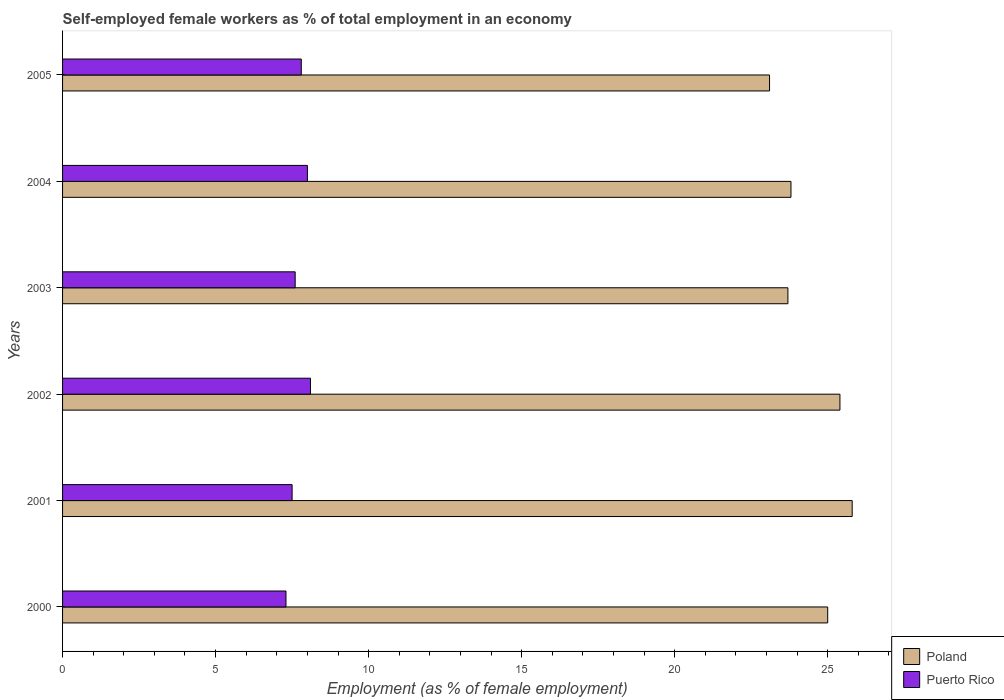How many different coloured bars are there?
Provide a short and direct response. 2. How many groups of bars are there?
Keep it short and to the point. 6. Are the number of bars per tick equal to the number of legend labels?
Ensure brevity in your answer.  Yes. How many bars are there on the 4th tick from the top?
Your answer should be very brief. 2. How many bars are there on the 1st tick from the bottom?
Provide a succinct answer. 2. What is the label of the 1st group of bars from the top?
Ensure brevity in your answer.  2005. In how many cases, is the number of bars for a given year not equal to the number of legend labels?
Your response must be concise. 0. What is the percentage of self-employed female workers in Poland in 2004?
Give a very brief answer. 23.8. Across all years, what is the maximum percentage of self-employed female workers in Poland?
Your answer should be compact. 25.8. Across all years, what is the minimum percentage of self-employed female workers in Puerto Rico?
Make the answer very short. 7.3. In which year was the percentage of self-employed female workers in Puerto Rico minimum?
Ensure brevity in your answer.  2000. What is the total percentage of self-employed female workers in Poland in the graph?
Provide a succinct answer. 146.8. What is the difference between the percentage of self-employed female workers in Puerto Rico in 2001 and that in 2005?
Give a very brief answer. -0.3. What is the difference between the percentage of self-employed female workers in Puerto Rico in 2001 and the percentage of self-employed female workers in Poland in 2002?
Make the answer very short. -17.9. What is the average percentage of self-employed female workers in Poland per year?
Make the answer very short. 24.47. In the year 2005, what is the difference between the percentage of self-employed female workers in Puerto Rico and percentage of self-employed female workers in Poland?
Your response must be concise. -15.3. What is the ratio of the percentage of self-employed female workers in Poland in 2000 to that in 2003?
Keep it short and to the point. 1.05. What is the difference between the highest and the second highest percentage of self-employed female workers in Poland?
Your answer should be very brief. 0.4. What is the difference between the highest and the lowest percentage of self-employed female workers in Puerto Rico?
Your answer should be compact. 0.8. In how many years, is the percentage of self-employed female workers in Poland greater than the average percentage of self-employed female workers in Poland taken over all years?
Provide a succinct answer. 3. Is the sum of the percentage of self-employed female workers in Puerto Rico in 2002 and 2003 greater than the maximum percentage of self-employed female workers in Poland across all years?
Your response must be concise. No. What does the 1st bar from the top in 2002 represents?
Keep it short and to the point. Puerto Rico. What does the 1st bar from the bottom in 2000 represents?
Ensure brevity in your answer.  Poland. How many bars are there?
Your response must be concise. 12. Are all the bars in the graph horizontal?
Offer a very short reply. Yes. Are the values on the major ticks of X-axis written in scientific E-notation?
Your answer should be compact. No. Does the graph contain any zero values?
Your response must be concise. No. Where does the legend appear in the graph?
Offer a terse response. Bottom right. How many legend labels are there?
Offer a very short reply. 2. How are the legend labels stacked?
Your answer should be compact. Vertical. What is the title of the graph?
Give a very brief answer. Self-employed female workers as % of total employment in an economy. Does "Turks and Caicos Islands" appear as one of the legend labels in the graph?
Offer a very short reply. No. What is the label or title of the X-axis?
Keep it short and to the point. Employment (as % of female employment). What is the label or title of the Y-axis?
Make the answer very short. Years. What is the Employment (as % of female employment) in Poland in 2000?
Provide a short and direct response. 25. What is the Employment (as % of female employment) in Puerto Rico in 2000?
Give a very brief answer. 7.3. What is the Employment (as % of female employment) in Poland in 2001?
Your answer should be compact. 25.8. What is the Employment (as % of female employment) of Poland in 2002?
Your answer should be very brief. 25.4. What is the Employment (as % of female employment) in Puerto Rico in 2002?
Your answer should be compact. 8.1. What is the Employment (as % of female employment) in Poland in 2003?
Your answer should be compact. 23.7. What is the Employment (as % of female employment) in Puerto Rico in 2003?
Ensure brevity in your answer.  7.6. What is the Employment (as % of female employment) in Poland in 2004?
Keep it short and to the point. 23.8. What is the Employment (as % of female employment) of Poland in 2005?
Make the answer very short. 23.1. What is the Employment (as % of female employment) in Puerto Rico in 2005?
Your answer should be compact. 7.8. Across all years, what is the maximum Employment (as % of female employment) of Poland?
Your response must be concise. 25.8. Across all years, what is the maximum Employment (as % of female employment) of Puerto Rico?
Ensure brevity in your answer.  8.1. Across all years, what is the minimum Employment (as % of female employment) in Poland?
Ensure brevity in your answer.  23.1. Across all years, what is the minimum Employment (as % of female employment) in Puerto Rico?
Ensure brevity in your answer.  7.3. What is the total Employment (as % of female employment) of Poland in the graph?
Give a very brief answer. 146.8. What is the total Employment (as % of female employment) of Puerto Rico in the graph?
Offer a very short reply. 46.3. What is the difference between the Employment (as % of female employment) of Poland in 2000 and that in 2001?
Provide a succinct answer. -0.8. What is the difference between the Employment (as % of female employment) in Puerto Rico in 2000 and that in 2001?
Your answer should be very brief. -0.2. What is the difference between the Employment (as % of female employment) in Poland in 2000 and that in 2002?
Your response must be concise. -0.4. What is the difference between the Employment (as % of female employment) in Puerto Rico in 2000 and that in 2002?
Offer a terse response. -0.8. What is the difference between the Employment (as % of female employment) in Poland in 2000 and that in 2003?
Offer a very short reply. 1.3. What is the difference between the Employment (as % of female employment) of Puerto Rico in 2000 and that in 2005?
Your answer should be very brief. -0.5. What is the difference between the Employment (as % of female employment) of Poland in 2001 and that in 2002?
Your response must be concise. 0.4. What is the difference between the Employment (as % of female employment) of Puerto Rico in 2001 and that in 2002?
Offer a terse response. -0.6. What is the difference between the Employment (as % of female employment) of Poland in 2001 and that in 2003?
Your answer should be very brief. 2.1. What is the difference between the Employment (as % of female employment) in Poland in 2001 and that in 2004?
Give a very brief answer. 2. What is the difference between the Employment (as % of female employment) in Puerto Rico in 2001 and that in 2004?
Give a very brief answer. -0.5. What is the difference between the Employment (as % of female employment) of Puerto Rico in 2001 and that in 2005?
Your answer should be compact. -0.3. What is the difference between the Employment (as % of female employment) in Poland in 2002 and that in 2003?
Offer a terse response. 1.7. What is the difference between the Employment (as % of female employment) of Puerto Rico in 2002 and that in 2003?
Ensure brevity in your answer.  0.5. What is the difference between the Employment (as % of female employment) in Puerto Rico in 2002 and that in 2004?
Keep it short and to the point. 0.1. What is the difference between the Employment (as % of female employment) of Puerto Rico in 2002 and that in 2005?
Provide a short and direct response. 0.3. What is the difference between the Employment (as % of female employment) in Puerto Rico in 2003 and that in 2004?
Offer a very short reply. -0.4. What is the difference between the Employment (as % of female employment) of Poland in 2003 and that in 2005?
Your answer should be compact. 0.6. What is the difference between the Employment (as % of female employment) of Poland in 2000 and the Employment (as % of female employment) of Puerto Rico in 2002?
Your response must be concise. 16.9. What is the difference between the Employment (as % of female employment) of Poland in 2000 and the Employment (as % of female employment) of Puerto Rico in 2003?
Ensure brevity in your answer.  17.4. What is the difference between the Employment (as % of female employment) of Poland in 2000 and the Employment (as % of female employment) of Puerto Rico in 2004?
Offer a very short reply. 17. What is the difference between the Employment (as % of female employment) of Poland in 2000 and the Employment (as % of female employment) of Puerto Rico in 2005?
Give a very brief answer. 17.2. What is the difference between the Employment (as % of female employment) in Poland in 2001 and the Employment (as % of female employment) in Puerto Rico in 2002?
Provide a short and direct response. 17.7. What is the difference between the Employment (as % of female employment) in Poland in 2003 and the Employment (as % of female employment) in Puerto Rico in 2004?
Give a very brief answer. 15.7. What is the difference between the Employment (as % of female employment) of Poland in 2003 and the Employment (as % of female employment) of Puerto Rico in 2005?
Your answer should be compact. 15.9. What is the difference between the Employment (as % of female employment) of Poland in 2004 and the Employment (as % of female employment) of Puerto Rico in 2005?
Your answer should be very brief. 16. What is the average Employment (as % of female employment) in Poland per year?
Ensure brevity in your answer.  24.47. What is the average Employment (as % of female employment) in Puerto Rico per year?
Offer a terse response. 7.72. In the year 2001, what is the difference between the Employment (as % of female employment) in Poland and Employment (as % of female employment) in Puerto Rico?
Your answer should be compact. 18.3. In the year 2003, what is the difference between the Employment (as % of female employment) in Poland and Employment (as % of female employment) in Puerto Rico?
Offer a very short reply. 16.1. In the year 2005, what is the difference between the Employment (as % of female employment) in Poland and Employment (as % of female employment) in Puerto Rico?
Give a very brief answer. 15.3. What is the ratio of the Employment (as % of female employment) of Puerto Rico in 2000 to that in 2001?
Your answer should be very brief. 0.97. What is the ratio of the Employment (as % of female employment) of Poland in 2000 to that in 2002?
Your answer should be compact. 0.98. What is the ratio of the Employment (as % of female employment) of Puerto Rico in 2000 to that in 2002?
Offer a very short reply. 0.9. What is the ratio of the Employment (as % of female employment) in Poland in 2000 to that in 2003?
Your response must be concise. 1.05. What is the ratio of the Employment (as % of female employment) in Puerto Rico in 2000 to that in 2003?
Give a very brief answer. 0.96. What is the ratio of the Employment (as % of female employment) in Poland in 2000 to that in 2004?
Keep it short and to the point. 1.05. What is the ratio of the Employment (as % of female employment) in Puerto Rico in 2000 to that in 2004?
Your response must be concise. 0.91. What is the ratio of the Employment (as % of female employment) in Poland in 2000 to that in 2005?
Keep it short and to the point. 1.08. What is the ratio of the Employment (as % of female employment) in Puerto Rico in 2000 to that in 2005?
Your answer should be compact. 0.94. What is the ratio of the Employment (as % of female employment) of Poland in 2001 to that in 2002?
Your response must be concise. 1.02. What is the ratio of the Employment (as % of female employment) in Puerto Rico in 2001 to that in 2002?
Offer a very short reply. 0.93. What is the ratio of the Employment (as % of female employment) in Poland in 2001 to that in 2003?
Your answer should be very brief. 1.09. What is the ratio of the Employment (as % of female employment) in Puerto Rico in 2001 to that in 2003?
Keep it short and to the point. 0.99. What is the ratio of the Employment (as % of female employment) of Poland in 2001 to that in 2004?
Keep it short and to the point. 1.08. What is the ratio of the Employment (as % of female employment) in Poland in 2001 to that in 2005?
Provide a succinct answer. 1.12. What is the ratio of the Employment (as % of female employment) of Puerto Rico in 2001 to that in 2005?
Your answer should be compact. 0.96. What is the ratio of the Employment (as % of female employment) in Poland in 2002 to that in 2003?
Provide a succinct answer. 1.07. What is the ratio of the Employment (as % of female employment) in Puerto Rico in 2002 to that in 2003?
Keep it short and to the point. 1.07. What is the ratio of the Employment (as % of female employment) in Poland in 2002 to that in 2004?
Your answer should be very brief. 1.07. What is the ratio of the Employment (as % of female employment) in Puerto Rico in 2002 to that in 2004?
Your response must be concise. 1.01. What is the ratio of the Employment (as % of female employment) of Poland in 2002 to that in 2005?
Make the answer very short. 1.1. What is the ratio of the Employment (as % of female employment) in Poland in 2003 to that in 2004?
Your answer should be very brief. 1. What is the ratio of the Employment (as % of female employment) in Puerto Rico in 2003 to that in 2004?
Offer a terse response. 0.95. What is the ratio of the Employment (as % of female employment) of Puerto Rico in 2003 to that in 2005?
Ensure brevity in your answer.  0.97. What is the ratio of the Employment (as % of female employment) of Poland in 2004 to that in 2005?
Offer a very short reply. 1.03. What is the ratio of the Employment (as % of female employment) in Puerto Rico in 2004 to that in 2005?
Ensure brevity in your answer.  1.03. What is the difference between the highest and the second highest Employment (as % of female employment) in Poland?
Give a very brief answer. 0.4. What is the difference between the highest and the lowest Employment (as % of female employment) of Poland?
Offer a very short reply. 2.7. 